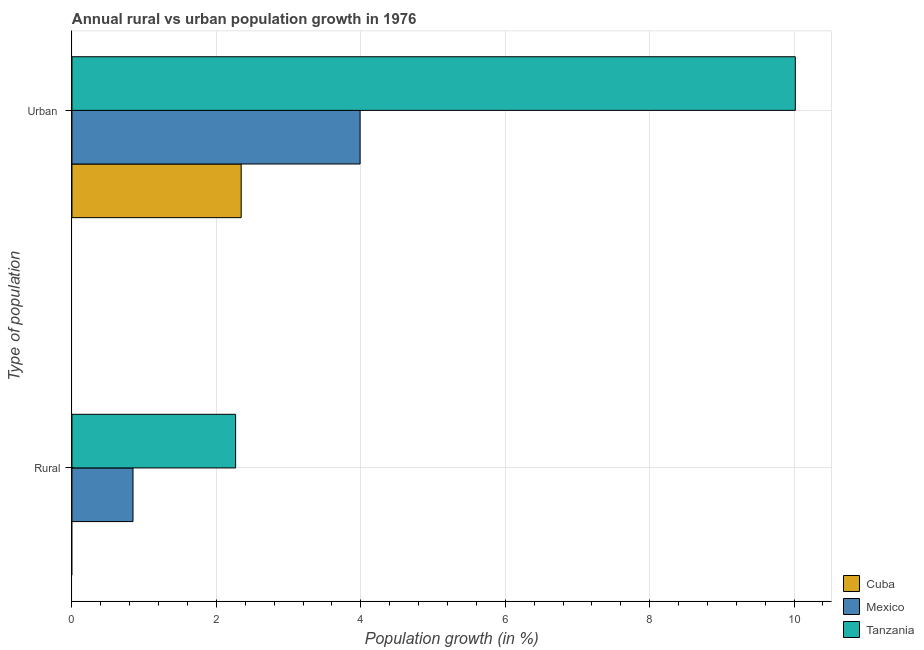How many different coloured bars are there?
Your answer should be compact. 3. How many groups of bars are there?
Your answer should be compact. 2. Are the number of bars per tick equal to the number of legend labels?
Your response must be concise. No. How many bars are there on the 1st tick from the top?
Keep it short and to the point. 3. How many bars are there on the 1st tick from the bottom?
Your response must be concise. 2. What is the label of the 1st group of bars from the top?
Provide a short and direct response. Urban . What is the urban population growth in Tanzania?
Give a very brief answer. 10.02. Across all countries, what is the maximum rural population growth?
Your response must be concise. 2.27. Across all countries, what is the minimum urban population growth?
Your answer should be very brief. 2.34. In which country was the rural population growth maximum?
Your response must be concise. Tanzania. What is the total rural population growth in the graph?
Ensure brevity in your answer.  3.11. What is the difference between the urban population growth in Tanzania and that in Cuba?
Your response must be concise. 7.67. What is the difference between the rural population growth in Mexico and the urban population growth in Tanzania?
Ensure brevity in your answer.  -9.17. What is the average rural population growth per country?
Offer a very short reply. 1.04. What is the difference between the urban population growth and rural population growth in Tanzania?
Your response must be concise. 7.75. What is the ratio of the urban population growth in Tanzania to that in Mexico?
Your response must be concise. 2.51. Is the rural population growth in Tanzania less than that in Mexico?
Ensure brevity in your answer.  No. In how many countries, is the rural population growth greater than the average rural population growth taken over all countries?
Offer a very short reply. 1. How many bars are there?
Your response must be concise. 5. Are all the bars in the graph horizontal?
Make the answer very short. Yes. How many countries are there in the graph?
Provide a succinct answer. 3. What is the difference between two consecutive major ticks on the X-axis?
Give a very brief answer. 2. Does the graph contain any zero values?
Provide a succinct answer. Yes. How many legend labels are there?
Your answer should be compact. 3. What is the title of the graph?
Make the answer very short. Annual rural vs urban population growth in 1976. What is the label or title of the X-axis?
Your answer should be very brief. Population growth (in %). What is the label or title of the Y-axis?
Provide a succinct answer. Type of population. What is the Population growth (in %) of Mexico in Rural?
Offer a terse response. 0.85. What is the Population growth (in %) in Tanzania in Rural?
Provide a short and direct response. 2.27. What is the Population growth (in %) of Cuba in Urban ?
Offer a very short reply. 2.34. What is the Population growth (in %) in Mexico in Urban ?
Make the answer very short. 3.99. What is the Population growth (in %) of Tanzania in Urban ?
Give a very brief answer. 10.02. Across all Type of population, what is the maximum Population growth (in %) of Cuba?
Provide a short and direct response. 2.34. Across all Type of population, what is the maximum Population growth (in %) in Mexico?
Your response must be concise. 3.99. Across all Type of population, what is the maximum Population growth (in %) of Tanzania?
Provide a short and direct response. 10.02. Across all Type of population, what is the minimum Population growth (in %) in Mexico?
Make the answer very short. 0.85. Across all Type of population, what is the minimum Population growth (in %) of Tanzania?
Offer a terse response. 2.27. What is the total Population growth (in %) in Cuba in the graph?
Give a very brief answer. 2.34. What is the total Population growth (in %) in Mexico in the graph?
Give a very brief answer. 4.84. What is the total Population growth (in %) of Tanzania in the graph?
Ensure brevity in your answer.  12.28. What is the difference between the Population growth (in %) in Mexico in Rural and that in Urban ?
Offer a terse response. -3.14. What is the difference between the Population growth (in %) of Tanzania in Rural and that in Urban ?
Provide a short and direct response. -7.75. What is the difference between the Population growth (in %) in Mexico in Rural and the Population growth (in %) in Tanzania in Urban ?
Provide a short and direct response. -9.17. What is the average Population growth (in %) in Cuba per Type of population?
Make the answer very short. 1.17. What is the average Population growth (in %) in Mexico per Type of population?
Provide a succinct answer. 2.42. What is the average Population growth (in %) in Tanzania per Type of population?
Ensure brevity in your answer.  6.14. What is the difference between the Population growth (in %) of Mexico and Population growth (in %) of Tanzania in Rural?
Your response must be concise. -1.42. What is the difference between the Population growth (in %) of Cuba and Population growth (in %) of Mexico in Urban ?
Offer a very short reply. -1.65. What is the difference between the Population growth (in %) of Cuba and Population growth (in %) of Tanzania in Urban ?
Your answer should be very brief. -7.67. What is the difference between the Population growth (in %) of Mexico and Population growth (in %) of Tanzania in Urban ?
Offer a very short reply. -6.03. What is the ratio of the Population growth (in %) in Mexico in Rural to that in Urban ?
Provide a succinct answer. 0.21. What is the ratio of the Population growth (in %) in Tanzania in Rural to that in Urban ?
Your answer should be very brief. 0.23. What is the difference between the highest and the second highest Population growth (in %) of Mexico?
Ensure brevity in your answer.  3.14. What is the difference between the highest and the second highest Population growth (in %) in Tanzania?
Your answer should be very brief. 7.75. What is the difference between the highest and the lowest Population growth (in %) in Cuba?
Make the answer very short. 2.34. What is the difference between the highest and the lowest Population growth (in %) in Mexico?
Give a very brief answer. 3.14. What is the difference between the highest and the lowest Population growth (in %) in Tanzania?
Your response must be concise. 7.75. 